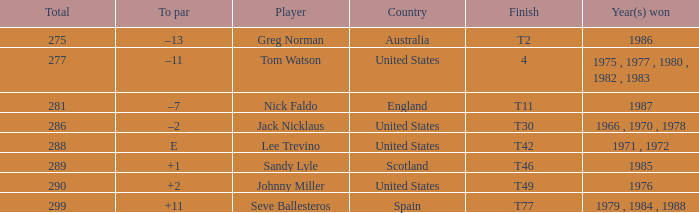What country had a finish of t49? United States. 